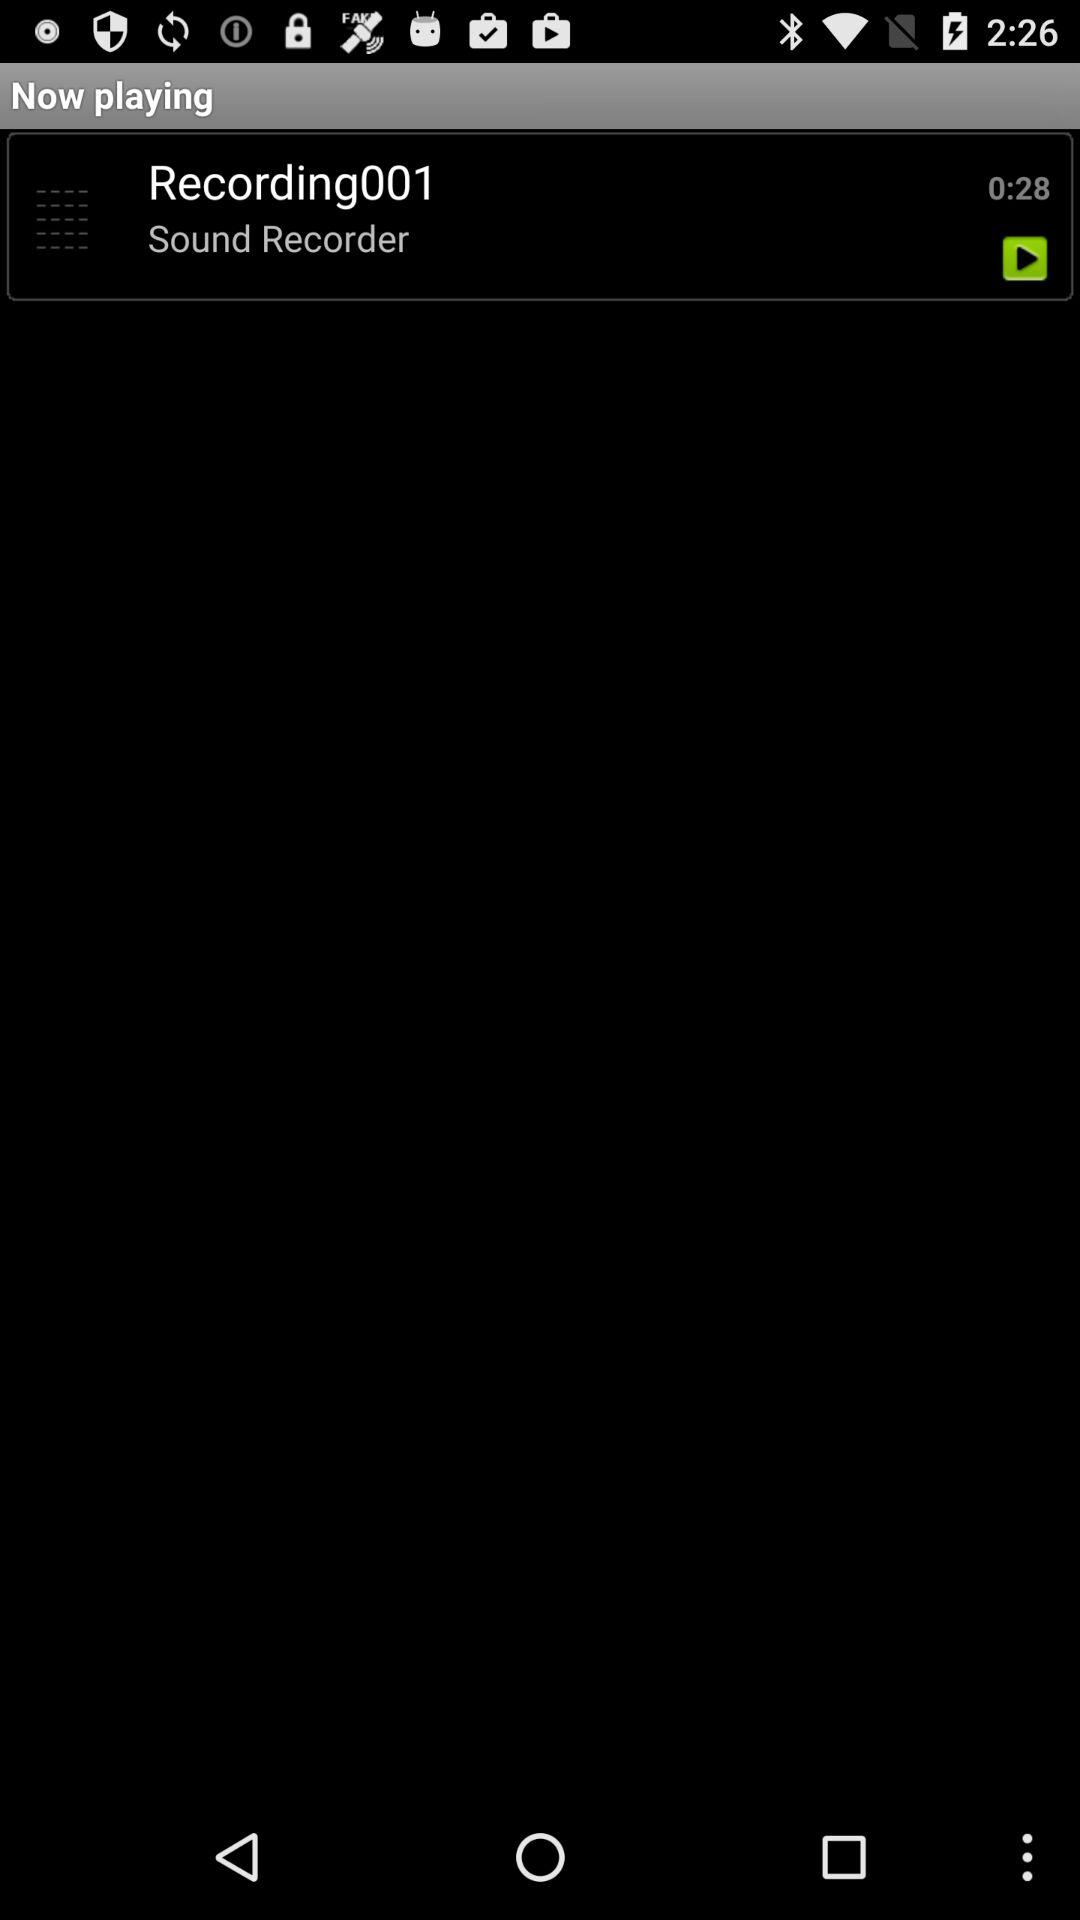How long is the recording?
Answer the question using a single word or phrase. 0:28 